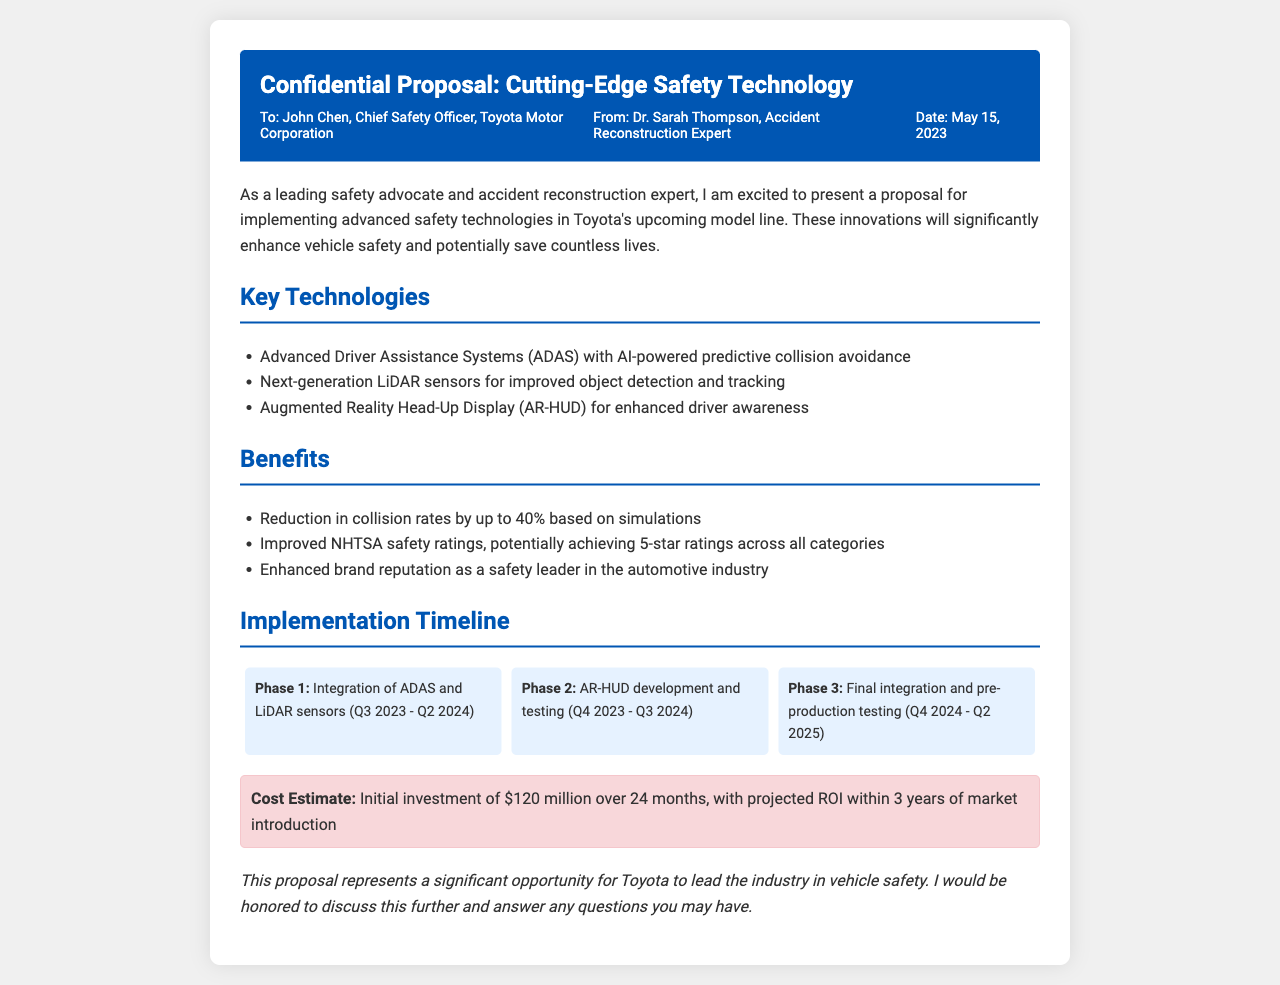What is the title of the proposal? The title of the proposal is clearly stated at the top of the document.
Answer: Cutting-Edge Safety Technology Who is the recipient of the proposal? The recipient's name is provided in the header information section of the document.
Answer: John Chen What is the projected cost estimate for the safety technology implementation? The document specifies the financial commitment required for the project.
Answer: $120 million What is the first phase of the implementation timeline? The first phase is mentioned in the timeline section with specific tasks and dates.
Answer: Integration of ADAS and LiDAR sensors (Q3 2023 - Q2 2024) How much reduction in collision rates is expected from the implementation? The document outlines the expected statistical improvement from the proposed technologies.
Answer: 40% What technological feature is mentioned for driver awareness enhancement? The proposal lists advanced features for enhancing a driver's awareness.
Answer: Augmented Reality Head-Up Display (AR-HUD) Which organization could potentially provide improved safety ratings? The document refers to an official organization responsible for safety ratings.
Answer: NHTSA How many phases are outlined for the implementation process? The timeline section details the segmentation of the implementation process.
Answer: 3 phases What is the conclusion of the proposal document? The conclusion summarizes the opportunity presented for the company.
Answer: This proposal represents a significant opportunity for Toyota to lead the industry in vehicle safety 